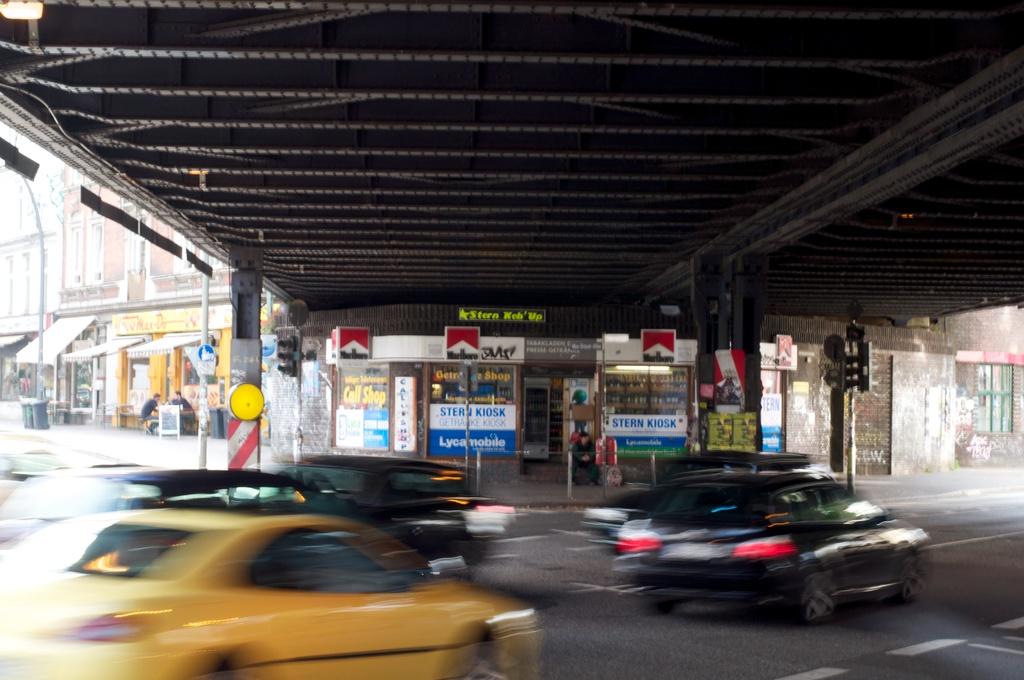What is the name of the kiosk?
Offer a very short reply. Unanswerable. 